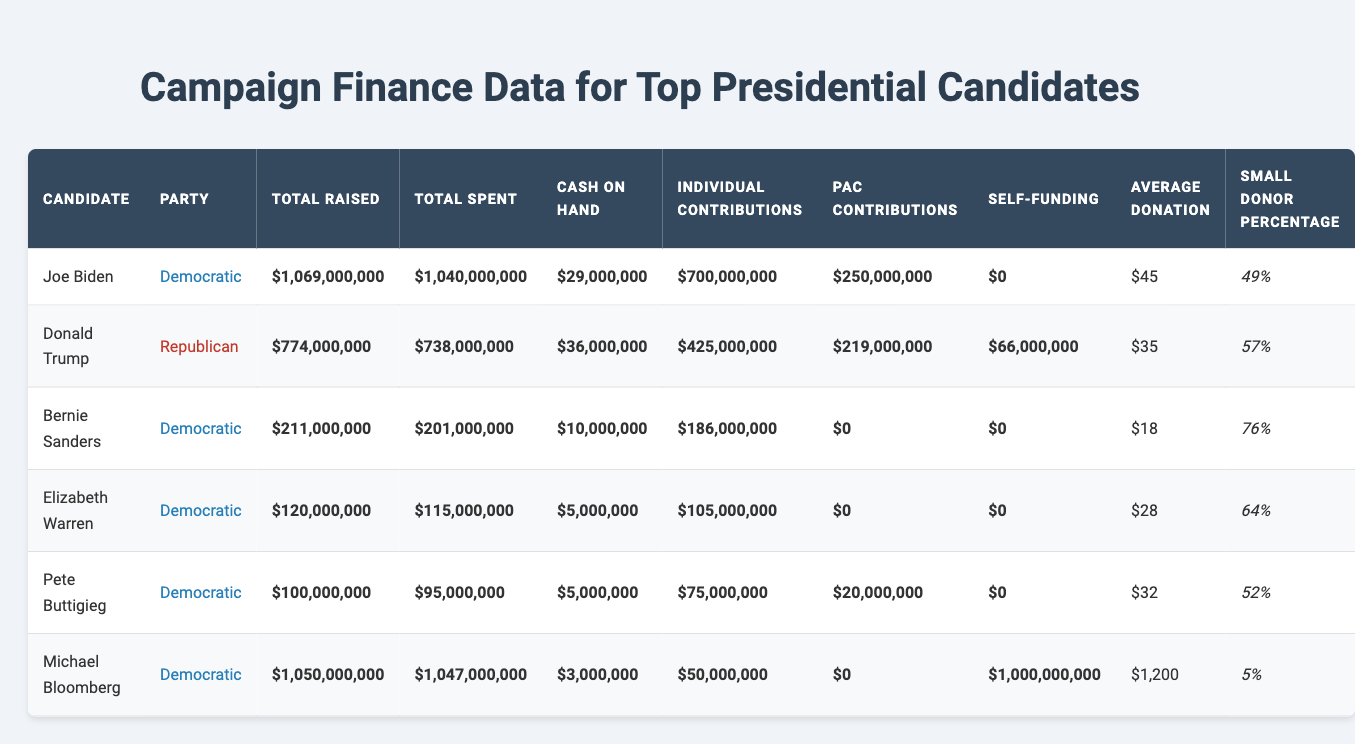What is the total amount raised by Joe Biden? The table shows the total raised amount for Joe Biden listed under the "Total Raised" column. It is stated as $1,069,000,000.
Answer: $1,069,000,000 Which candidate had the highest cash on hand? By looking at the "Cash on Hand" column, Joe Biden has $29,000,000, Donald Trump has $36,000,000, and other candidates have less. Therefore, Donald Trump has the highest cash on hand.
Answer: Donald Trump What is the small donor percentage for Bernie Sanders? The table lists the small donor percentage for Bernie Sanders under the "Small Donor Percentage" column as 76%.
Answer: 76% How much more did Michael Bloomberg spend than he raised? Michael Bloomberg raised $1,050,000,000 and spent $1,047,000,000. Subtracting these gives $1,050,000,000 - $1,047,000,000 = $3,000,000.
Answer: $3,000,000 Did any candidate use self-funding? The table shows that Michael Bloomberg listed self-funding of $1,000,000,000, while other candidates had $0 in this category. This indicates that yes, Michael Bloomberg used self-funding.
Answer: Yes Which Democratic candidate had the lowest average donation? The average donations are $45 for Joe Biden, $18 for Bernie Sanders, $28 for Elizabeth Warren, and $32 for Pete Buttigieg. Bernie Sanders has the lowest average donation at $18.
Answer: Bernie Sanders Is the total raised by Donald Trump greater than the combined total raised by Elizabeth Warren and Pete Buttigieg? Donald Trump raised $774,000,000. Elizabeth Warren raised $120,000,000 and Pete Buttigieg raised $100,000,000, giving a combined total of $220,000,000. Since $774,000,000 is greater than $220,000,000, the answer is yes.
Answer: Yes What percentage of contributions for Joe Biden came from PACs? The total contributions for Joe Biden include $250,000,000 from PAC contributions out of $1,069,000,000 total raised. The percentage would be calculated as ($250,000,000 / $1,069,000,000) * 100 ≈ 23.4%.
Answer: 23.4% Who was the only candidate to not receive PAC contributions? Looking through the table, it shows Bernie Sanders and Elizabeth Warren have $0 in the PAC Contributions column as well, but since they are both Democatic candidates, I will refer to them differently than the others. The only candidate among the top list who is noted for zero PAC contributions clearly is Bernie Sanders.
Answer: Bernie Sanders Calculate the total amount raised by all Democratic candidates. The Democratic candidates' total raised is Joe Biden ($1,069,000,000) + Bernie Sanders ($211,000,000) + Elizabeth Warren ($120,000,000) + Pete Buttigieg ($100,000,000) + Michael Bloomberg ($1,050,000,000) = $2,550,000,000.
Answer: $2,550,000,000 